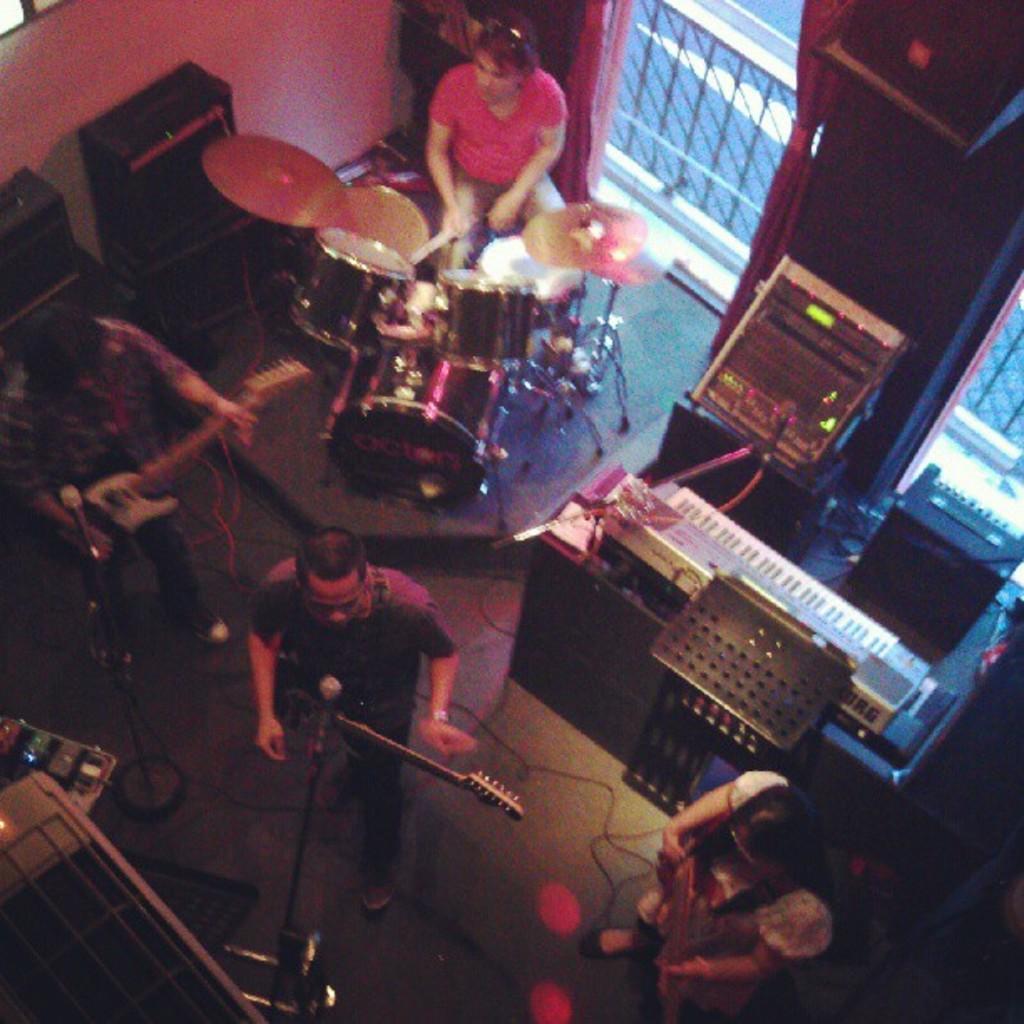Could you give a brief overview of what you see in this image? IN the house there are four people. One man is holding a guitar in front of microphone and aside to that person one more man is holding a guitar. And beside that man a woman is sitting on a chair and playing musical instruments, drums beside to it there is a keyboard and music box next to it there is a window with the curtain. 